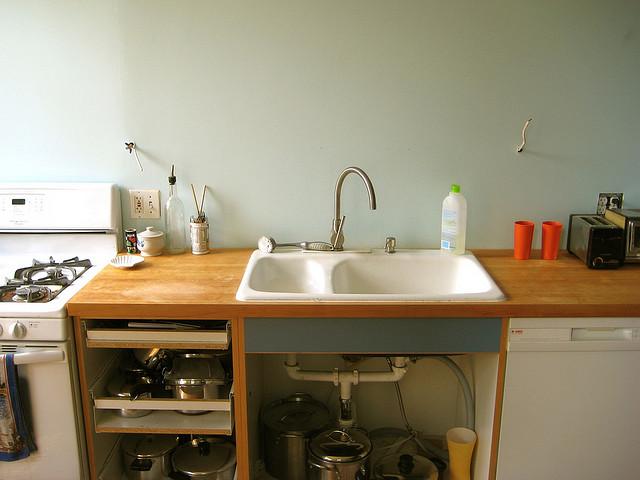Is the dishwasher door closed?
Be succinct. Yes. What happened to the cabinets doors?
Short answer required. Removed. What type of room is this?
Answer briefly. Kitchen. Which side of the picture is the outlet without any paneling on?
Short answer required. Right. 